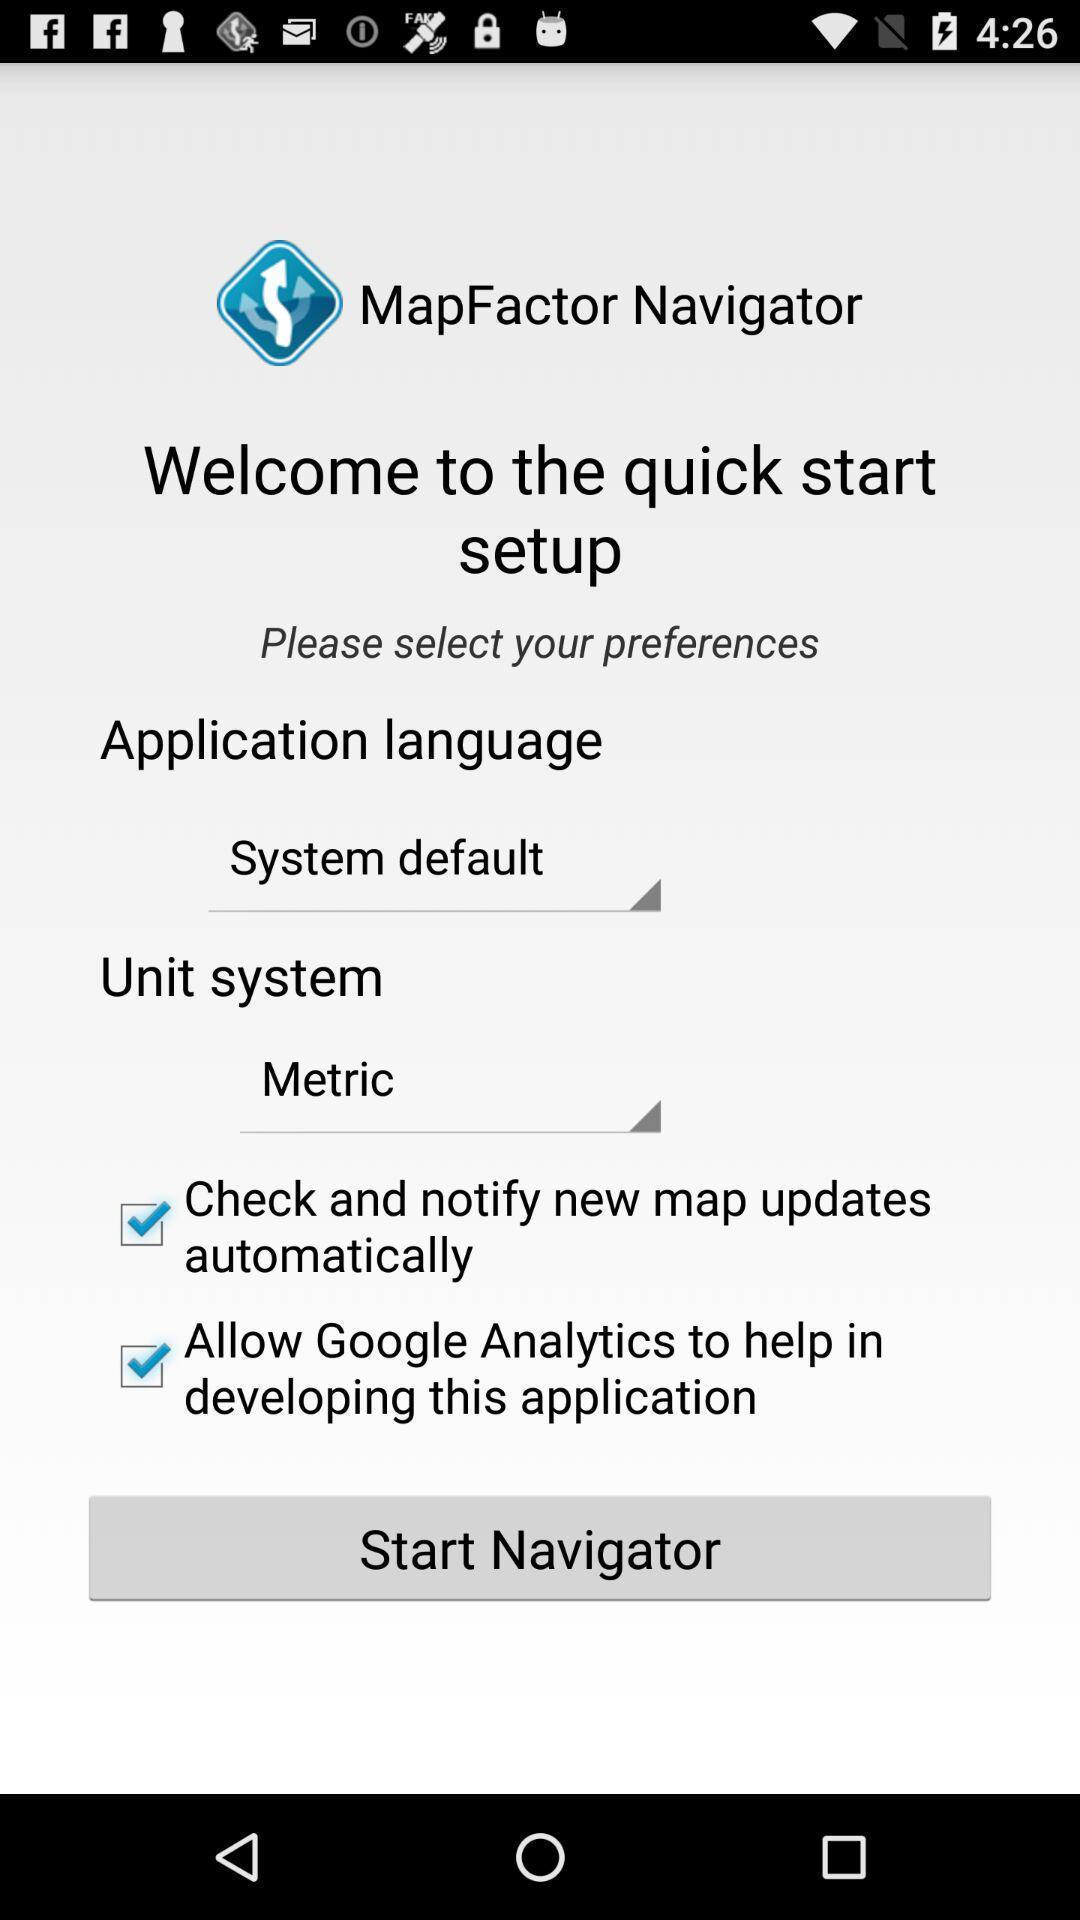Tell me what you see in this picture. Welcome page of a offline navigation app. 